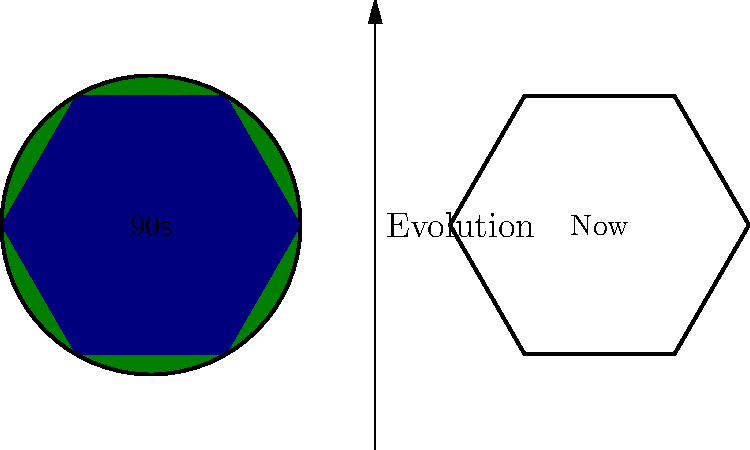Based on the simplified representation of NFL team logo evolution from the 90s to present, what is the most notable change in design philosophy? To answer this question, let's analyze the changes step-by-step:

1. Shape: The 90s logo is represented by a circle, while the modern logo is shown as a hexagon. This indicates a shift from rounded, simple shapes to more complex, angular designs.

2. Color: The 90s logo uses a green fill, reminiscent of traditional team colors like the Green Bay Packers. The modern logo uses a blue fill, suggesting a trend towards bolder, more diverse color palettes.

3. Complexity: The 90s logo is a single, basic shape. The modern logo, being a hexagon, hints at increased complexity and detail in current designs.

4. Style: The arrow between the logos suggests an evolution or modernization of design philosophies over time.

5. Branding: The shift from a simple, easily recognizable shape to a more intricate one reflects changing branding strategies in the NFL, likely aimed at merchandising and digital media applications.

The most notable change, considering all these factors, is the shift from simple, traditional designs to more complex, modern aesthetics. This encompasses changes in shape, color, and overall visual complexity.
Answer: Shift from simple to complex designs 